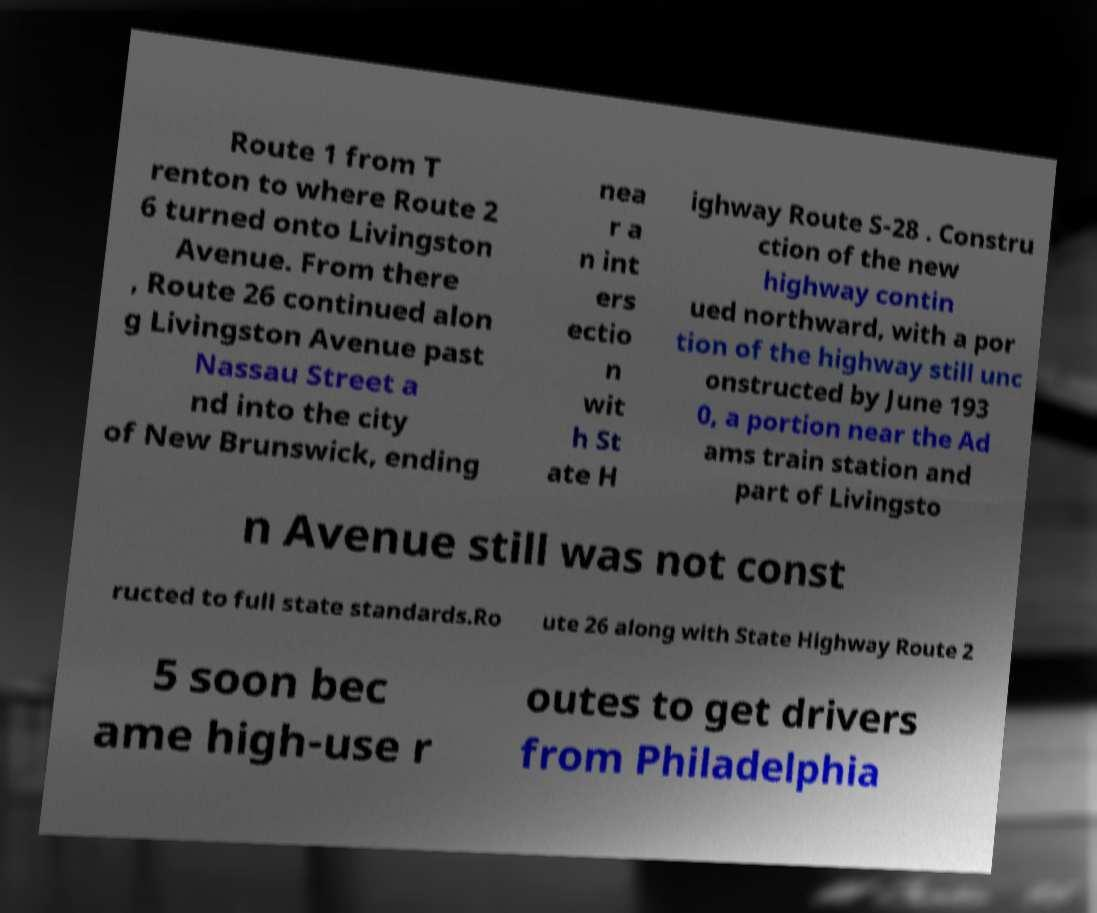Can you read and provide the text displayed in the image?This photo seems to have some interesting text. Can you extract and type it out for me? Route 1 from T renton to where Route 2 6 turned onto Livingston Avenue. From there , Route 26 continued alon g Livingston Avenue past Nassau Street a nd into the city of New Brunswick, ending nea r a n int ers ectio n wit h St ate H ighway Route S-28 . Constru ction of the new highway contin ued northward, with a por tion of the highway still unc onstructed by June 193 0, a portion near the Ad ams train station and part of Livingsto n Avenue still was not const ructed to full state standards.Ro ute 26 along with State Highway Route 2 5 soon bec ame high-use r outes to get drivers from Philadelphia 